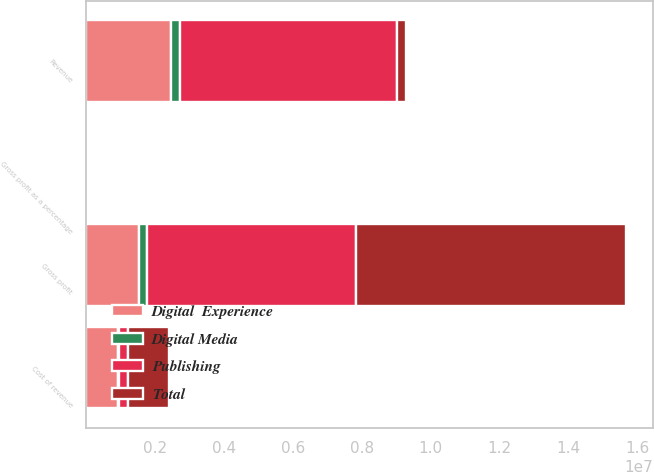<chart> <loc_0><loc_0><loc_500><loc_500><stacked_bar_chart><ecel><fcel>Revenue<fcel>Cost of revenue<fcel>Gross profit<fcel>Gross profit as a percentage<nl><fcel>Publishing<fcel>6.32532e+06<fcel>249386<fcel>6.07593e+06<fcel>96<nl><fcel>Digital  Experience<fcel>2.44374e+06<fcel>922414<fcel>1.52133e+06<fcel>62<nl><fcel>Digital Media<fcel>260948<fcel>23199<fcel>237749<fcel>91<nl><fcel>Total<fcel>260948<fcel>1.195e+06<fcel>7.83501e+06<fcel>87<nl></chart> 